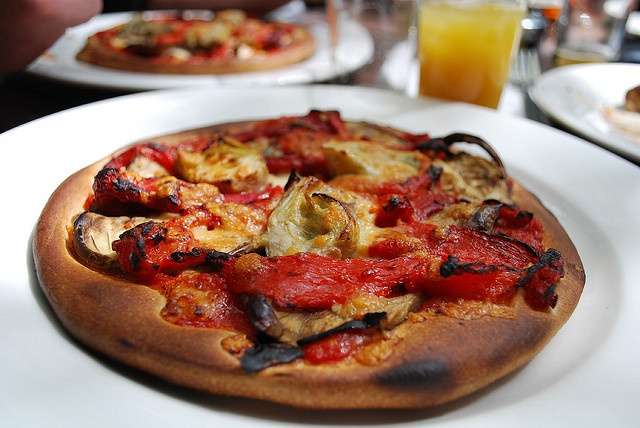Describe the objects in this image and their specific colors. I can see pizza in black, maroon, and brown tones, pizza in black, brown, and maroon tones, cup in black, olive, orange, and tan tones, and fork in black, darkgray, gray, and tan tones in this image. 